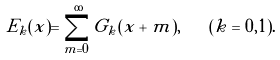Convert formula to latex. <formula><loc_0><loc_0><loc_500><loc_500>E _ { k } ( x ) = \sum _ { m = 0 } ^ { \infty } G _ { k } ( x + m ) , \quad ( k = 0 , 1 ) .</formula> 